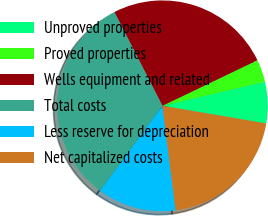<chart> <loc_0><loc_0><loc_500><loc_500><pie_chart><fcel>Unproved properties<fcel>Proved properties<fcel>Wells equipment and related<fcel>Total costs<fcel>Less reserve for depreciation<fcel>Net capitalized costs<nl><fcel>6.35%<fcel>3.45%<fcel>25.41%<fcel>32.39%<fcel>12.08%<fcel>20.32%<nl></chart> 